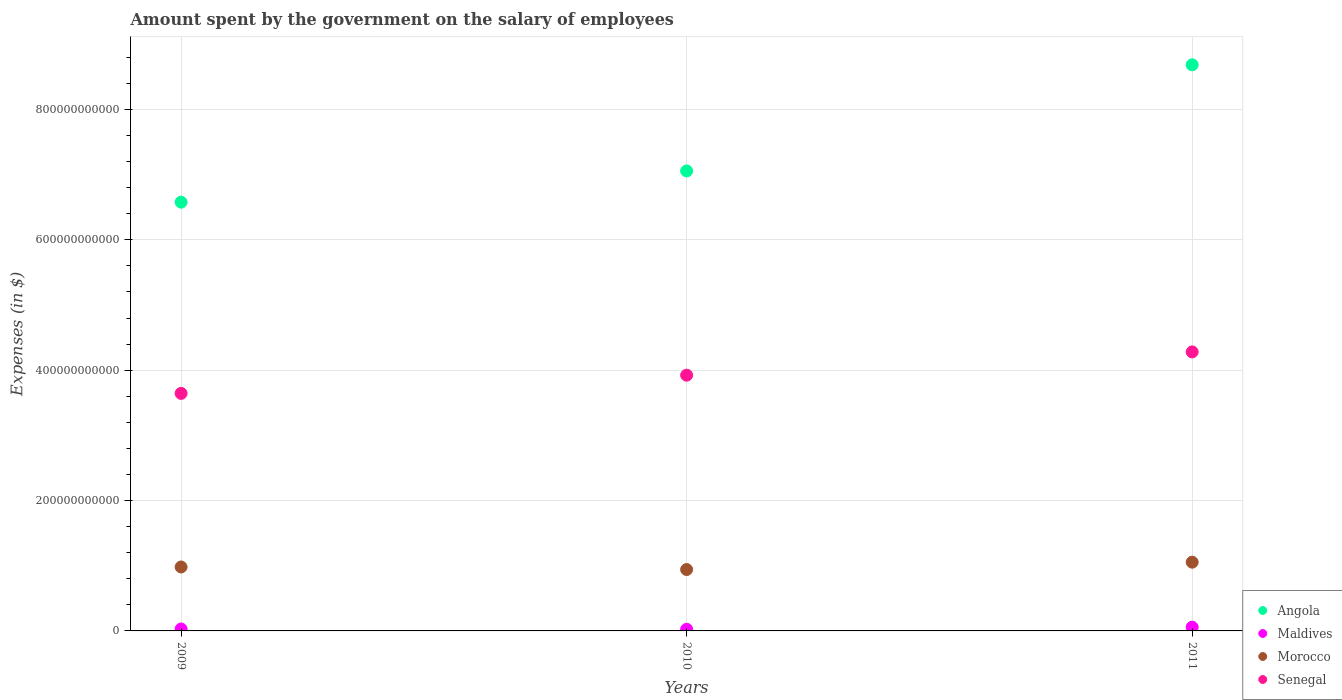What is the amount spent on the salary of employees by the government in Maldives in 2010?
Offer a terse response. 2.49e+09. Across all years, what is the maximum amount spent on the salary of employees by the government in Senegal?
Ensure brevity in your answer.  4.28e+11. Across all years, what is the minimum amount spent on the salary of employees by the government in Senegal?
Make the answer very short. 3.64e+11. What is the total amount spent on the salary of employees by the government in Senegal in the graph?
Offer a very short reply. 1.18e+12. What is the difference between the amount spent on the salary of employees by the government in Morocco in 2009 and that in 2011?
Give a very brief answer. -7.38e+09. What is the difference between the amount spent on the salary of employees by the government in Morocco in 2010 and the amount spent on the salary of employees by the government in Angola in 2009?
Give a very brief answer. -5.64e+11. What is the average amount spent on the salary of employees by the government in Maldives per year?
Offer a very short reply. 3.72e+09. In the year 2010, what is the difference between the amount spent on the salary of employees by the government in Morocco and amount spent on the salary of employees by the government in Angola?
Offer a very short reply. -6.11e+11. In how many years, is the amount spent on the salary of employees by the government in Senegal greater than 760000000000 $?
Keep it short and to the point. 0. What is the ratio of the amount spent on the salary of employees by the government in Angola in 2010 to that in 2011?
Give a very brief answer. 0.81. What is the difference between the highest and the second highest amount spent on the salary of employees by the government in Angola?
Provide a short and direct response. 1.63e+11. What is the difference between the highest and the lowest amount spent on the salary of employees by the government in Angola?
Give a very brief answer. 2.11e+11. Is it the case that in every year, the sum of the amount spent on the salary of employees by the government in Senegal and amount spent on the salary of employees by the government in Angola  is greater than the sum of amount spent on the salary of employees by the government in Morocco and amount spent on the salary of employees by the government in Maldives?
Ensure brevity in your answer.  No. Is it the case that in every year, the sum of the amount spent on the salary of employees by the government in Morocco and amount spent on the salary of employees by the government in Senegal  is greater than the amount spent on the salary of employees by the government in Angola?
Make the answer very short. No. How many dotlines are there?
Make the answer very short. 4. What is the difference between two consecutive major ticks on the Y-axis?
Make the answer very short. 2.00e+11. Does the graph contain grids?
Provide a short and direct response. Yes. Where does the legend appear in the graph?
Provide a succinct answer. Bottom right. How many legend labels are there?
Ensure brevity in your answer.  4. How are the legend labels stacked?
Make the answer very short. Vertical. What is the title of the graph?
Your answer should be compact. Amount spent by the government on the salary of employees. Does "Channel Islands" appear as one of the legend labels in the graph?
Offer a terse response. No. What is the label or title of the Y-axis?
Offer a very short reply. Expenses (in $). What is the Expenses (in $) of Angola in 2009?
Provide a succinct answer. 6.58e+11. What is the Expenses (in $) of Maldives in 2009?
Your answer should be compact. 2.94e+09. What is the Expenses (in $) in Morocco in 2009?
Provide a short and direct response. 9.81e+1. What is the Expenses (in $) in Senegal in 2009?
Provide a succinct answer. 3.64e+11. What is the Expenses (in $) in Angola in 2010?
Your answer should be compact. 7.06e+11. What is the Expenses (in $) of Maldives in 2010?
Offer a terse response. 2.49e+09. What is the Expenses (in $) in Morocco in 2010?
Offer a very short reply. 9.42e+1. What is the Expenses (in $) of Senegal in 2010?
Give a very brief answer. 3.92e+11. What is the Expenses (in $) of Angola in 2011?
Your answer should be compact. 8.68e+11. What is the Expenses (in $) in Maldives in 2011?
Keep it short and to the point. 5.73e+09. What is the Expenses (in $) in Morocco in 2011?
Make the answer very short. 1.05e+11. What is the Expenses (in $) of Senegal in 2011?
Offer a very short reply. 4.28e+11. Across all years, what is the maximum Expenses (in $) of Angola?
Provide a succinct answer. 8.68e+11. Across all years, what is the maximum Expenses (in $) of Maldives?
Your response must be concise. 5.73e+09. Across all years, what is the maximum Expenses (in $) in Morocco?
Provide a succinct answer. 1.05e+11. Across all years, what is the maximum Expenses (in $) of Senegal?
Offer a terse response. 4.28e+11. Across all years, what is the minimum Expenses (in $) of Angola?
Your response must be concise. 6.58e+11. Across all years, what is the minimum Expenses (in $) of Maldives?
Offer a terse response. 2.49e+09. Across all years, what is the minimum Expenses (in $) of Morocco?
Offer a very short reply. 9.42e+1. Across all years, what is the minimum Expenses (in $) in Senegal?
Provide a succinct answer. 3.64e+11. What is the total Expenses (in $) in Angola in the graph?
Give a very brief answer. 2.23e+12. What is the total Expenses (in $) in Maldives in the graph?
Your answer should be very brief. 1.12e+1. What is the total Expenses (in $) of Morocco in the graph?
Your answer should be very brief. 2.98e+11. What is the total Expenses (in $) of Senegal in the graph?
Provide a succinct answer. 1.18e+12. What is the difference between the Expenses (in $) in Angola in 2009 and that in 2010?
Offer a very short reply. -4.79e+1. What is the difference between the Expenses (in $) in Maldives in 2009 and that in 2010?
Offer a very short reply. 4.58e+08. What is the difference between the Expenses (in $) of Morocco in 2009 and that in 2010?
Your answer should be very brief. 3.92e+09. What is the difference between the Expenses (in $) of Senegal in 2009 and that in 2010?
Offer a very short reply. -2.79e+1. What is the difference between the Expenses (in $) in Angola in 2009 and that in 2011?
Offer a terse response. -2.11e+11. What is the difference between the Expenses (in $) in Maldives in 2009 and that in 2011?
Your answer should be compact. -2.78e+09. What is the difference between the Expenses (in $) of Morocco in 2009 and that in 2011?
Make the answer very short. -7.38e+09. What is the difference between the Expenses (in $) of Senegal in 2009 and that in 2011?
Provide a succinct answer. -6.36e+1. What is the difference between the Expenses (in $) of Angola in 2010 and that in 2011?
Provide a succinct answer. -1.63e+11. What is the difference between the Expenses (in $) of Maldives in 2010 and that in 2011?
Your response must be concise. -3.24e+09. What is the difference between the Expenses (in $) in Morocco in 2010 and that in 2011?
Offer a very short reply. -1.13e+1. What is the difference between the Expenses (in $) of Senegal in 2010 and that in 2011?
Provide a short and direct response. -3.57e+1. What is the difference between the Expenses (in $) of Angola in 2009 and the Expenses (in $) of Maldives in 2010?
Your response must be concise. 6.55e+11. What is the difference between the Expenses (in $) in Angola in 2009 and the Expenses (in $) in Morocco in 2010?
Your answer should be very brief. 5.64e+11. What is the difference between the Expenses (in $) in Angola in 2009 and the Expenses (in $) in Senegal in 2010?
Your answer should be compact. 2.65e+11. What is the difference between the Expenses (in $) of Maldives in 2009 and the Expenses (in $) of Morocco in 2010?
Keep it short and to the point. -9.12e+1. What is the difference between the Expenses (in $) in Maldives in 2009 and the Expenses (in $) in Senegal in 2010?
Provide a short and direct response. -3.89e+11. What is the difference between the Expenses (in $) of Morocco in 2009 and the Expenses (in $) of Senegal in 2010?
Your answer should be very brief. -2.94e+11. What is the difference between the Expenses (in $) of Angola in 2009 and the Expenses (in $) of Maldives in 2011?
Your answer should be compact. 6.52e+11. What is the difference between the Expenses (in $) in Angola in 2009 and the Expenses (in $) in Morocco in 2011?
Make the answer very short. 5.52e+11. What is the difference between the Expenses (in $) in Angola in 2009 and the Expenses (in $) in Senegal in 2011?
Give a very brief answer. 2.30e+11. What is the difference between the Expenses (in $) of Maldives in 2009 and the Expenses (in $) of Morocco in 2011?
Keep it short and to the point. -1.03e+11. What is the difference between the Expenses (in $) of Maldives in 2009 and the Expenses (in $) of Senegal in 2011?
Your response must be concise. -4.25e+11. What is the difference between the Expenses (in $) of Morocco in 2009 and the Expenses (in $) of Senegal in 2011?
Offer a very short reply. -3.30e+11. What is the difference between the Expenses (in $) in Angola in 2010 and the Expenses (in $) in Maldives in 2011?
Your response must be concise. 7.00e+11. What is the difference between the Expenses (in $) in Angola in 2010 and the Expenses (in $) in Morocco in 2011?
Your response must be concise. 6.00e+11. What is the difference between the Expenses (in $) of Angola in 2010 and the Expenses (in $) of Senegal in 2011?
Ensure brevity in your answer.  2.78e+11. What is the difference between the Expenses (in $) in Maldives in 2010 and the Expenses (in $) in Morocco in 2011?
Offer a very short reply. -1.03e+11. What is the difference between the Expenses (in $) of Maldives in 2010 and the Expenses (in $) of Senegal in 2011?
Your response must be concise. -4.26e+11. What is the difference between the Expenses (in $) in Morocco in 2010 and the Expenses (in $) in Senegal in 2011?
Make the answer very short. -3.34e+11. What is the average Expenses (in $) of Angola per year?
Your response must be concise. 7.44e+11. What is the average Expenses (in $) of Maldives per year?
Provide a short and direct response. 3.72e+09. What is the average Expenses (in $) of Morocco per year?
Give a very brief answer. 9.92e+1. What is the average Expenses (in $) of Senegal per year?
Your answer should be very brief. 3.95e+11. In the year 2009, what is the difference between the Expenses (in $) of Angola and Expenses (in $) of Maldives?
Your response must be concise. 6.55e+11. In the year 2009, what is the difference between the Expenses (in $) in Angola and Expenses (in $) in Morocco?
Keep it short and to the point. 5.60e+11. In the year 2009, what is the difference between the Expenses (in $) in Angola and Expenses (in $) in Senegal?
Offer a very short reply. 2.93e+11. In the year 2009, what is the difference between the Expenses (in $) in Maldives and Expenses (in $) in Morocco?
Ensure brevity in your answer.  -9.51e+1. In the year 2009, what is the difference between the Expenses (in $) in Maldives and Expenses (in $) in Senegal?
Your answer should be very brief. -3.61e+11. In the year 2009, what is the difference between the Expenses (in $) of Morocco and Expenses (in $) of Senegal?
Provide a succinct answer. -2.66e+11. In the year 2010, what is the difference between the Expenses (in $) of Angola and Expenses (in $) of Maldives?
Ensure brevity in your answer.  7.03e+11. In the year 2010, what is the difference between the Expenses (in $) in Angola and Expenses (in $) in Morocco?
Provide a short and direct response. 6.11e+11. In the year 2010, what is the difference between the Expenses (in $) in Angola and Expenses (in $) in Senegal?
Keep it short and to the point. 3.13e+11. In the year 2010, what is the difference between the Expenses (in $) in Maldives and Expenses (in $) in Morocco?
Make the answer very short. -9.17e+1. In the year 2010, what is the difference between the Expenses (in $) of Maldives and Expenses (in $) of Senegal?
Provide a short and direct response. -3.90e+11. In the year 2010, what is the difference between the Expenses (in $) in Morocco and Expenses (in $) in Senegal?
Ensure brevity in your answer.  -2.98e+11. In the year 2011, what is the difference between the Expenses (in $) in Angola and Expenses (in $) in Maldives?
Ensure brevity in your answer.  8.63e+11. In the year 2011, what is the difference between the Expenses (in $) of Angola and Expenses (in $) of Morocco?
Your response must be concise. 7.63e+11. In the year 2011, what is the difference between the Expenses (in $) in Angola and Expenses (in $) in Senegal?
Give a very brief answer. 4.40e+11. In the year 2011, what is the difference between the Expenses (in $) of Maldives and Expenses (in $) of Morocco?
Give a very brief answer. -9.97e+1. In the year 2011, what is the difference between the Expenses (in $) of Maldives and Expenses (in $) of Senegal?
Provide a succinct answer. -4.22e+11. In the year 2011, what is the difference between the Expenses (in $) in Morocco and Expenses (in $) in Senegal?
Make the answer very short. -3.23e+11. What is the ratio of the Expenses (in $) of Angola in 2009 to that in 2010?
Make the answer very short. 0.93. What is the ratio of the Expenses (in $) in Maldives in 2009 to that in 2010?
Provide a succinct answer. 1.18. What is the ratio of the Expenses (in $) in Morocco in 2009 to that in 2010?
Offer a terse response. 1.04. What is the ratio of the Expenses (in $) of Senegal in 2009 to that in 2010?
Offer a terse response. 0.93. What is the ratio of the Expenses (in $) in Angola in 2009 to that in 2011?
Ensure brevity in your answer.  0.76. What is the ratio of the Expenses (in $) of Maldives in 2009 to that in 2011?
Keep it short and to the point. 0.51. What is the ratio of the Expenses (in $) of Morocco in 2009 to that in 2011?
Keep it short and to the point. 0.93. What is the ratio of the Expenses (in $) of Senegal in 2009 to that in 2011?
Offer a very short reply. 0.85. What is the ratio of the Expenses (in $) of Angola in 2010 to that in 2011?
Offer a very short reply. 0.81. What is the ratio of the Expenses (in $) in Maldives in 2010 to that in 2011?
Offer a terse response. 0.43. What is the ratio of the Expenses (in $) in Morocco in 2010 to that in 2011?
Make the answer very short. 0.89. What is the ratio of the Expenses (in $) of Senegal in 2010 to that in 2011?
Offer a terse response. 0.92. What is the difference between the highest and the second highest Expenses (in $) of Angola?
Offer a terse response. 1.63e+11. What is the difference between the highest and the second highest Expenses (in $) in Maldives?
Offer a very short reply. 2.78e+09. What is the difference between the highest and the second highest Expenses (in $) in Morocco?
Provide a succinct answer. 7.38e+09. What is the difference between the highest and the second highest Expenses (in $) in Senegal?
Provide a short and direct response. 3.57e+1. What is the difference between the highest and the lowest Expenses (in $) in Angola?
Provide a short and direct response. 2.11e+11. What is the difference between the highest and the lowest Expenses (in $) of Maldives?
Your answer should be very brief. 3.24e+09. What is the difference between the highest and the lowest Expenses (in $) in Morocco?
Your answer should be very brief. 1.13e+1. What is the difference between the highest and the lowest Expenses (in $) of Senegal?
Your answer should be very brief. 6.36e+1. 